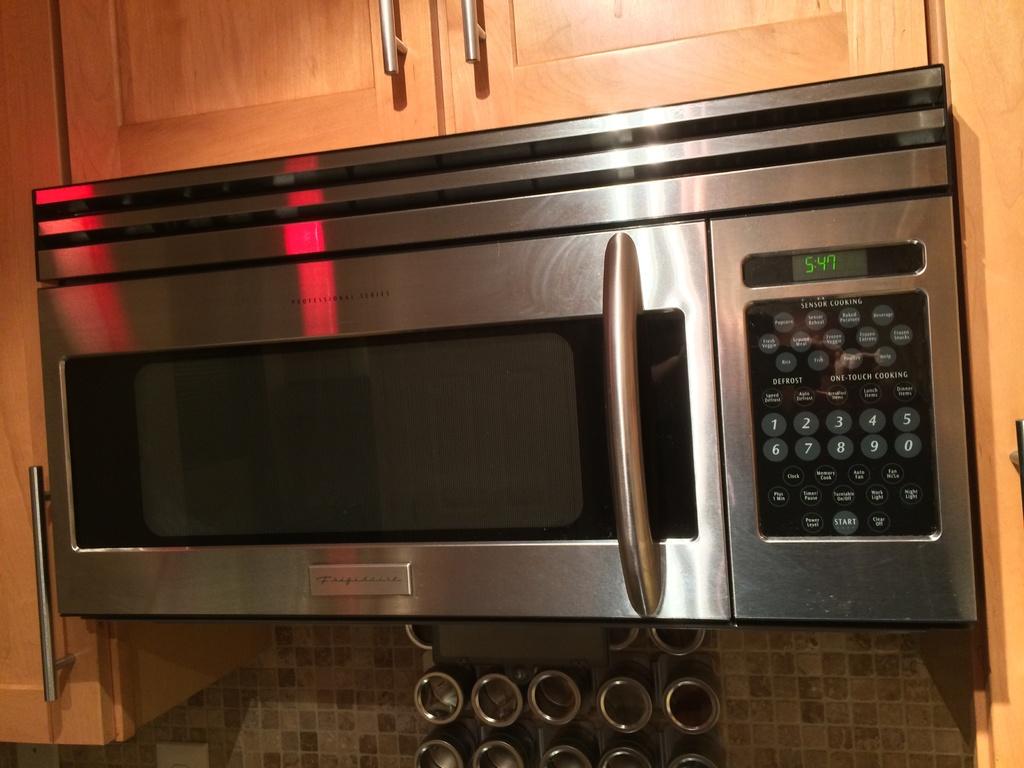What time is it displaying?
Offer a terse response. 5:47. What number is the last one on the first row?
Ensure brevity in your answer.  5. 